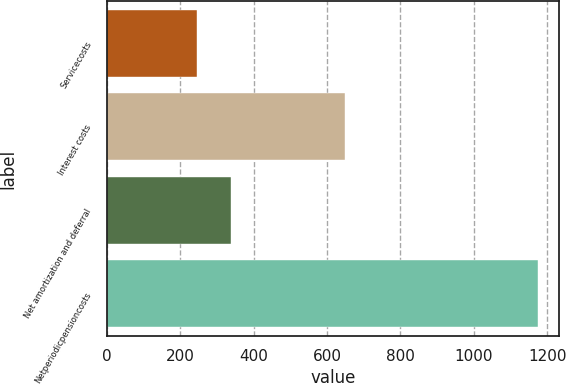Convert chart to OTSL. <chart><loc_0><loc_0><loc_500><loc_500><bar_chart><fcel>Servicecosts<fcel>Interest costs<fcel>Net amortization and deferral<fcel>Netperiodicpensioncosts<nl><fcel>247<fcel>650<fcel>339.7<fcel>1174<nl></chart> 